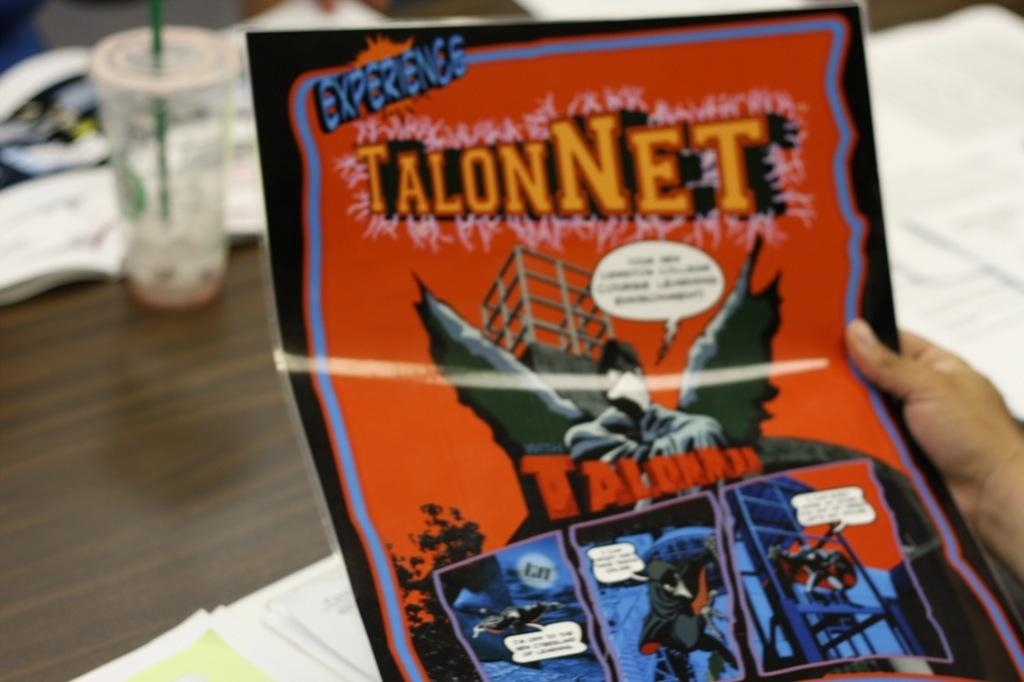<image>
Share a concise interpretation of the image provided. Someone is holding a poster that says TalonNet on it. 